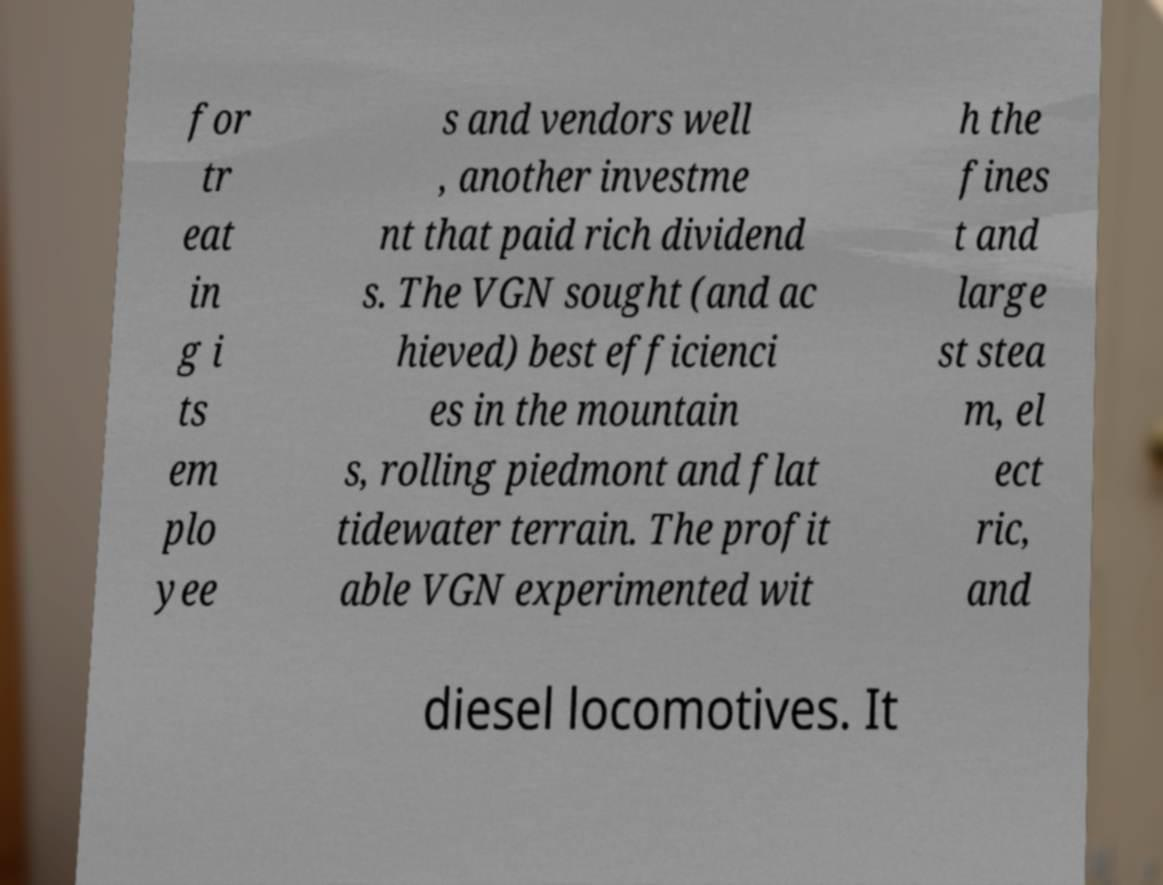Could you extract and type out the text from this image? for tr eat in g i ts em plo yee s and vendors well , another investme nt that paid rich dividend s. The VGN sought (and ac hieved) best efficienci es in the mountain s, rolling piedmont and flat tidewater terrain. The profit able VGN experimented wit h the fines t and large st stea m, el ect ric, and diesel locomotives. It 